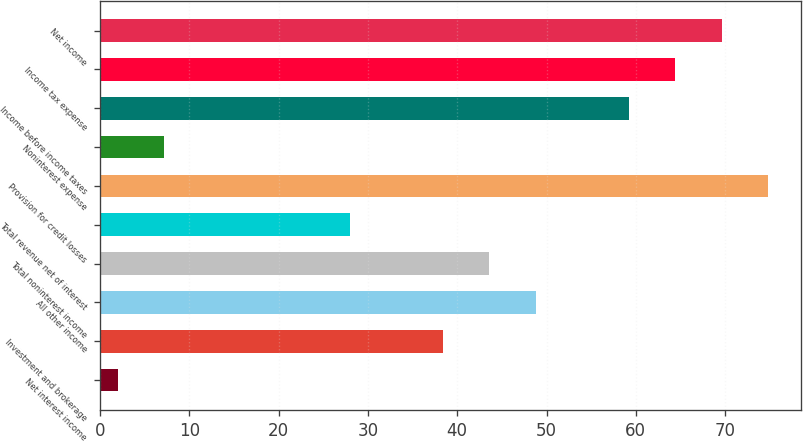Convert chart to OTSL. <chart><loc_0><loc_0><loc_500><loc_500><bar_chart><fcel>Net interest income<fcel>Investment and brokerage<fcel>All other income<fcel>Total noninterest income<fcel>Total revenue net of interest<fcel>Provision for credit losses<fcel>Noninterest expense<fcel>Income before income taxes<fcel>Income tax expense<fcel>Net income<nl><fcel>2<fcel>38.4<fcel>48.8<fcel>43.6<fcel>28<fcel>74.8<fcel>7.2<fcel>59.2<fcel>64.4<fcel>69.6<nl></chart> 